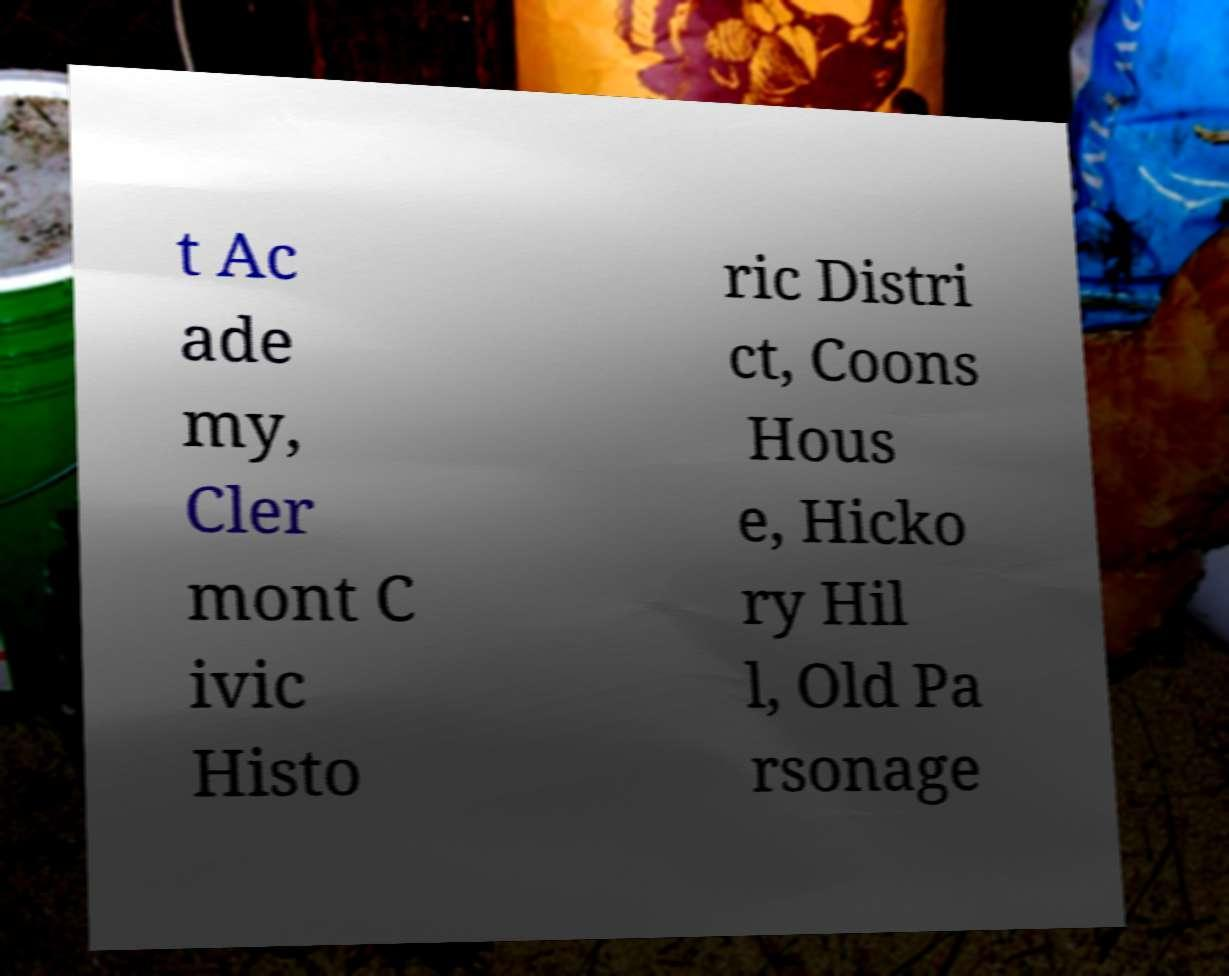What messages or text are displayed in this image? I need them in a readable, typed format. t Ac ade my, Cler mont C ivic Histo ric Distri ct, Coons Hous e, Hicko ry Hil l, Old Pa rsonage 